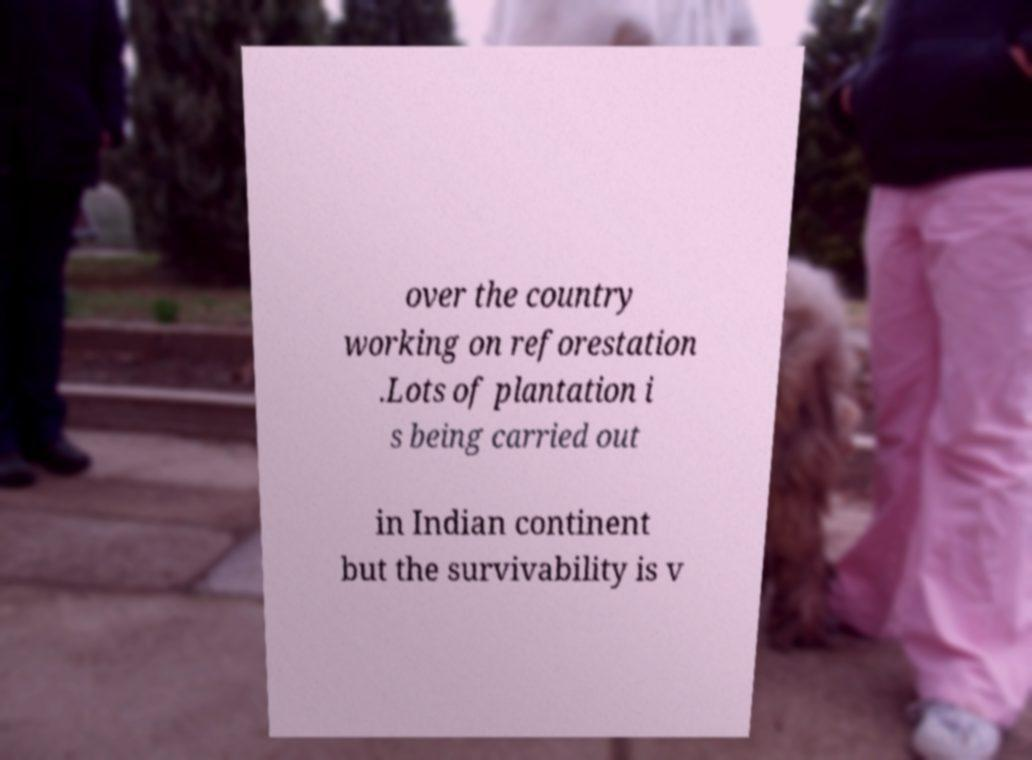Could you assist in decoding the text presented in this image and type it out clearly? over the country working on reforestation .Lots of plantation i s being carried out in Indian continent but the survivability is v 